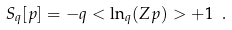Convert formula to latex. <formula><loc_0><loc_0><loc_500><loc_500>S _ { q } [ p ] = - q < \ln _ { q } ( Z p ) > + 1 \ .</formula> 